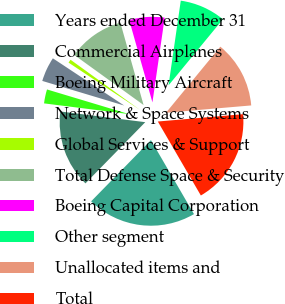Convert chart to OTSL. <chart><loc_0><loc_0><loc_500><loc_500><pie_chart><fcel>Years ended December 31<fcel>Commercial Airplanes<fcel>Boeing Military Aircraft<fcel>Network & Space Systems<fcel>Global Services & Support<fcel>Total Defense Space & Security<fcel>Boeing Capital Corporation<fcel>Other segment<fcel>Unallocated items and<fcel>Total<nl><fcel>20.7%<fcel>14.68%<fcel>2.65%<fcel>4.66%<fcel>0.65%<fcel>10.67%<fcel>6.66%<fcel>8.67%<fcel>12.68%<fcel>17.98%<nl></chart> 